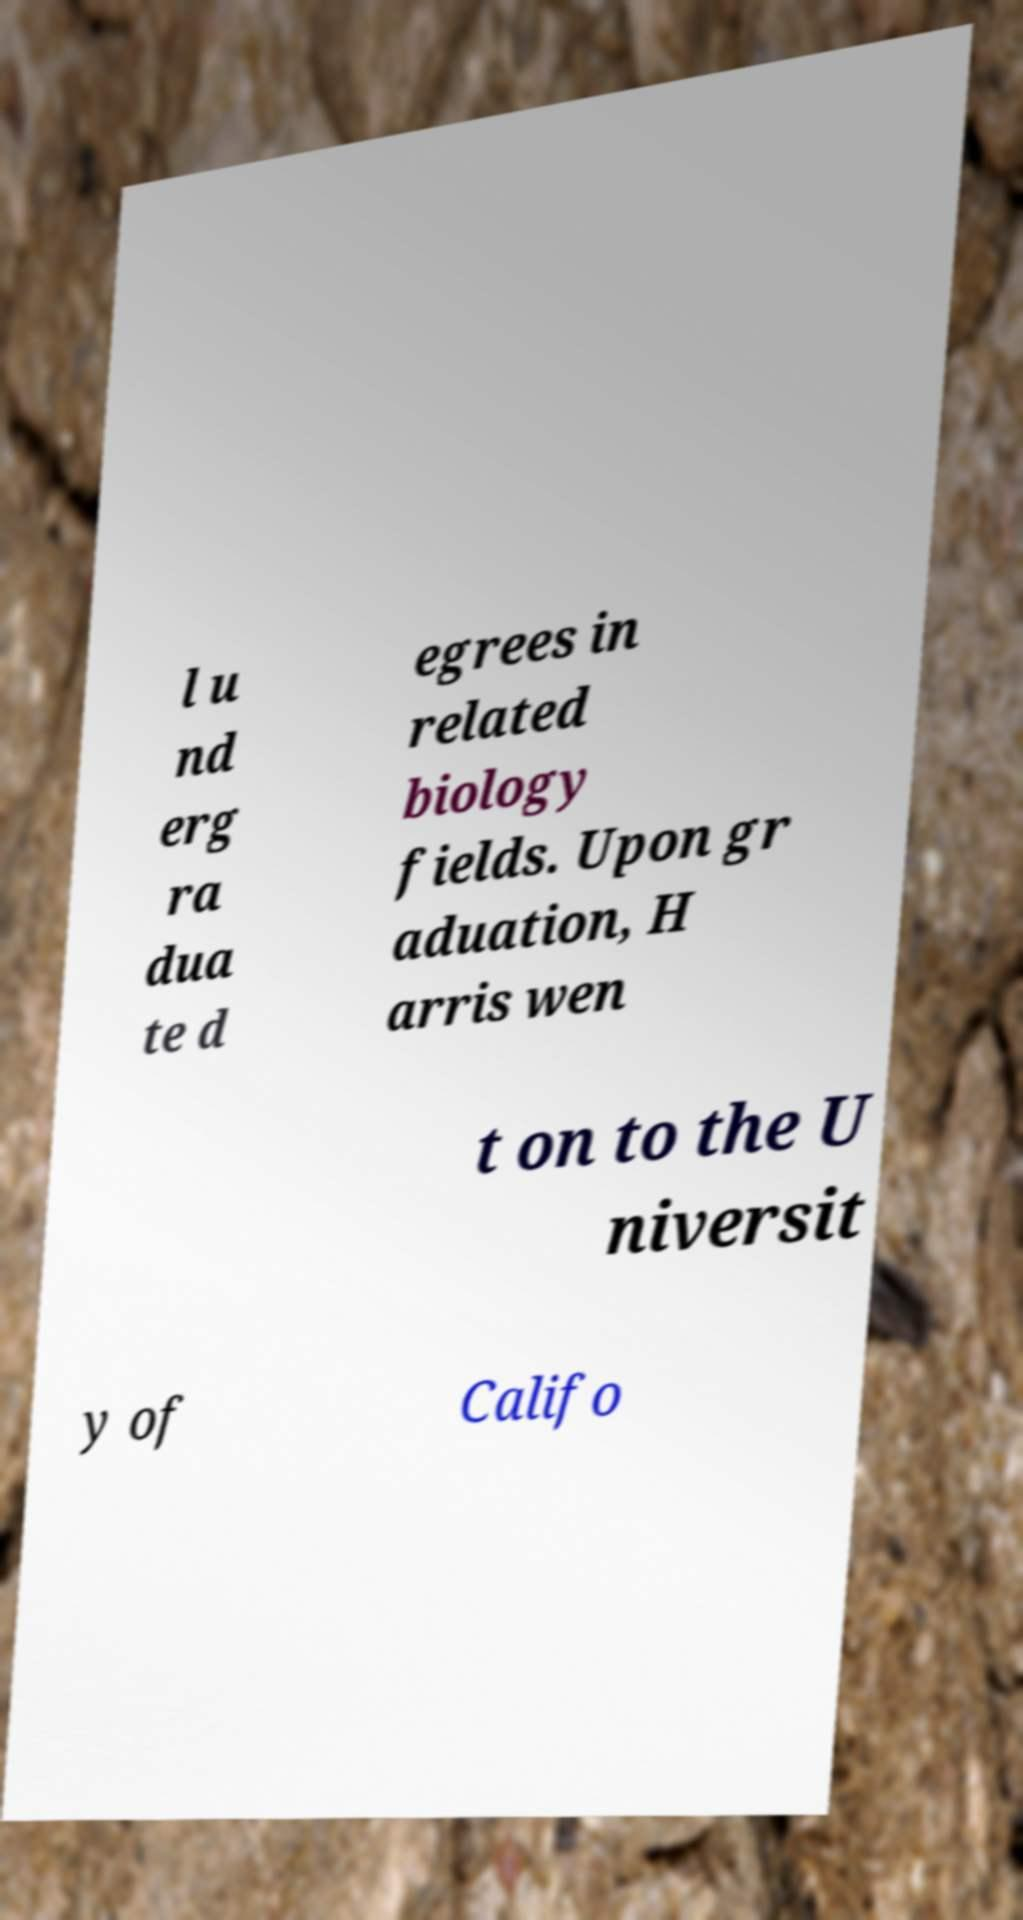What messages or text are displayed in this image? I need them in a readable, typed format. l u nd erg ra dua te d egrees in related biology fields. Upon gr aduation, H arris wen t on to the U niversit y of Califo 